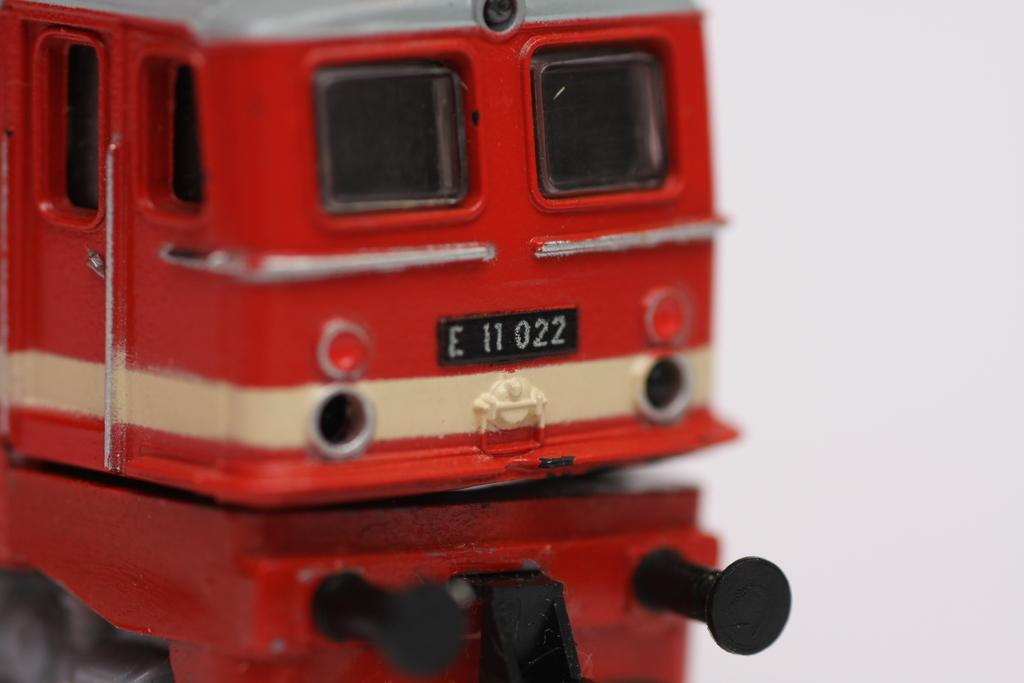<image>
Summarize the visual content of the image. A red double deck bus toy has the license plate number E 11 0022. 